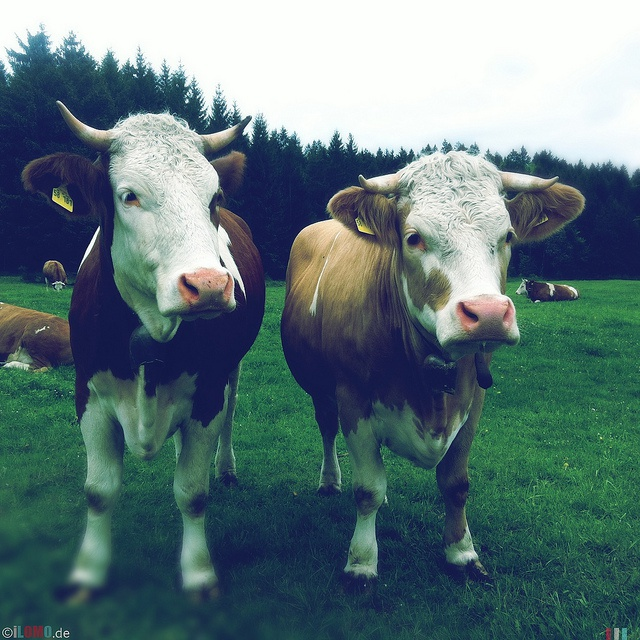Describe the objects in this image and their specific colors. I can see cow in white, navy, lightgray, and teal tones, cow in white, navy, gray, lightgray, and teal tones, cow in white, navy, gray, and olive tones, cow in white, navy, gray, darkgray, and teal tones, and cow in white, gray, navy, black, and teal tones in this image. 